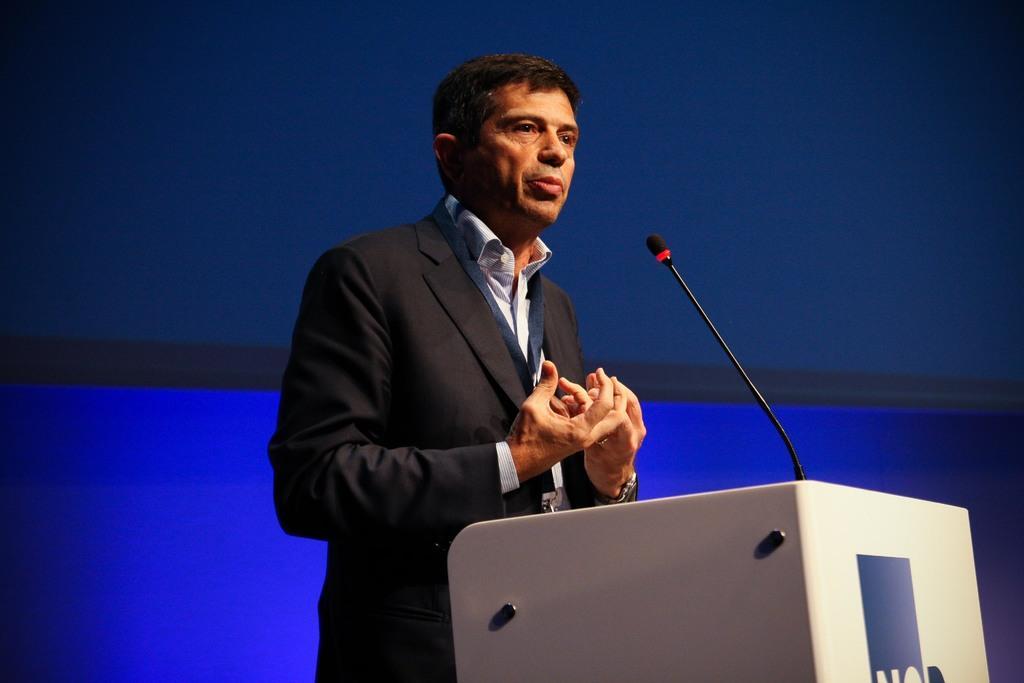In one or two sentences, can you explain what this image depicts? In this image we can see a man is standing at the podium and there is a microphone on the podium. In the background we can see objects. 